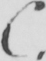What text is written in this handwritten line? C . 